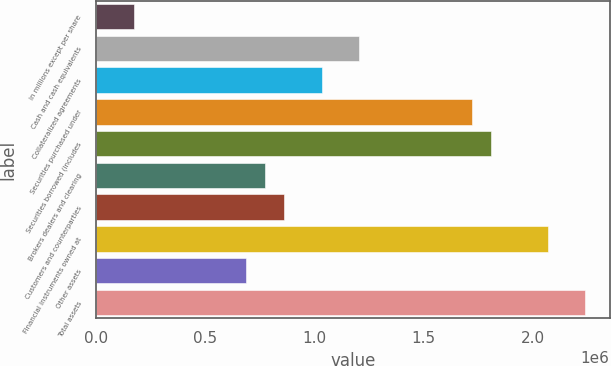<chart> <loc_0><loc_0><loc_500><loc_500><bar_chart><fcel>in millions except per share<fcel>Cash and cash equivalents<fcel>Collateralized agreements<fcel>Securities purchased under<fcel>Securities borrowed (includes<fcel>Brokers dealers and clearing<fcel>Customers and counterparties<fcel>Financial instruments owned at<fcel>Other assets<fcel>Total assets<nl><fcel>172286<fcel>1.20595e+06<fcel>1.03367e+06<fcel>1.72278e+06<fcel>1.80892e+06<fcel>775256<fcel>861395<fcel>2.06734e+06<fcel>689118<fcel>2.23961e+06<nl></chart> 